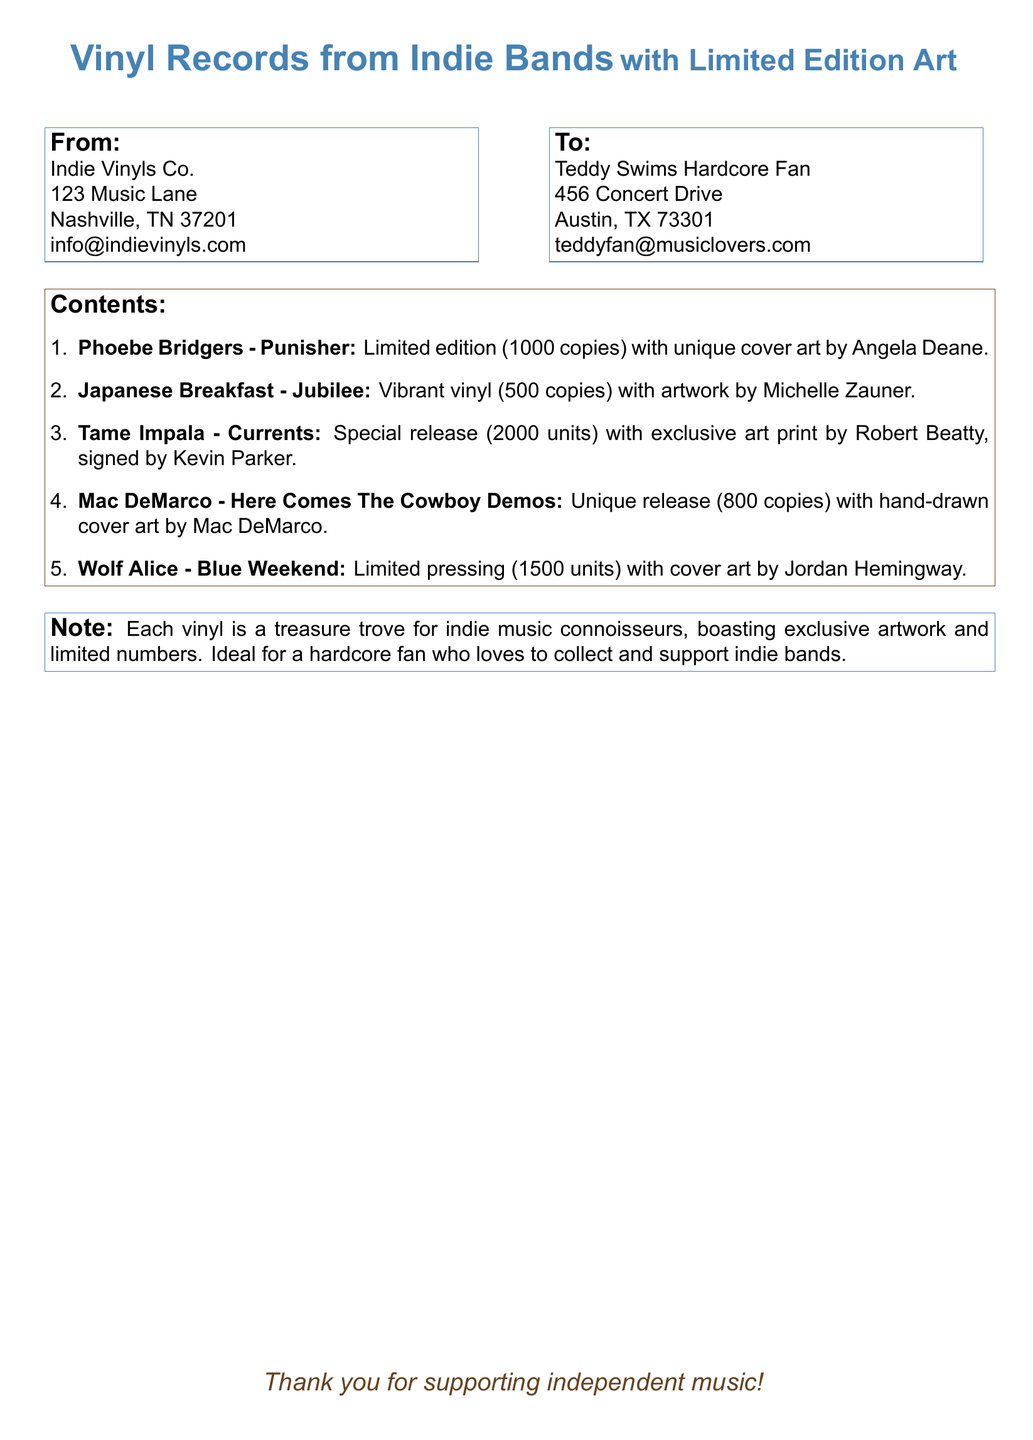What is the name of the sender? The sender's name is Indie Vinyls Co. provided in the "From" section of the shipping label.
Answer: Indie Vinyls Co What is the city of the recipient? The city listed for the recipient in the "To" section of the shipping label is provided as part of the address.
Answer: Austin How many copies of Phoebe Bridgers - Punisher were produced? The document lists that there are 1000 copies of Phoebe Bridgers - Punisher in the contents section.
Answer: 1000 copies Who created the artwork for Japanese Breakfast - Jubilee? The document specifies that the artwork for Japanese Breakfast - Jubilee was done by Michelle Zauner.
Answer: Michelle Zauner What is the total number of vinyl records listed? The total number of unique vinyl records mentioned in the "Contents" section can be counted from the bullet points.
Answer: 5 Which vinyl has a signed art print? The document states that Tame Impala - Currents has an exclusive art print signed by Kevin Parker.
Answer: Tame Impala - Currents What is the unique feature of the Mac DeMarco - Here Comes The Cowboy Demos? The document mentions that Mac DeMarco - Here Comes The Cowboy Demos has hand-drawn cover art.
Answer: Hand-drawn cover art What is the message conveyed at the bottom of the shipping label? The message at the bottom of the document appreciates the support for independent music.
Answer: Thank you for supporting independent music! 